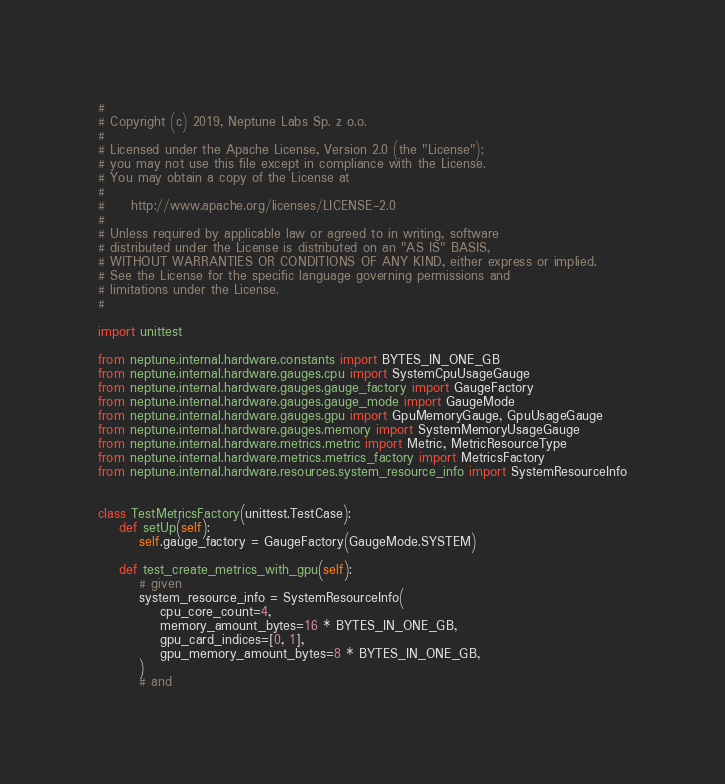Convert code to text. <code><loc_0><loc_0><loc_500><loc_500><_Python_>#
# Copyright (c) 2019, Neptune Labs Sp. z o.o.
#
# Licensed under the Apache License, Version 2.0 (the "License");
# you may not use this file except in compliance with the License.
# You may obtain a copy of the License at
#
#     http://www.apache.org/licenses/LICENSE-2.0
#
# Unless required by applicable law or agreed to in writing, software
# distributed under the License is distributed on an "AS IS" BASIS,
# WITHOUT WARRANTIES OR CONDITIONS OF ANY KIND, either express or implied.
# See the License for the specific language governing permissions and
# limitations under the License.
#

import unittest

from neptune.internal.hardware.constants import BYTES_IN_ONE_GB
from neptune.internal.hardware.gauges.cpu import SystemCpuUsageGauge
from neptune.internal.hardware.gauges.gauge_factory import GaugeFactory
from neptune.internal.hardware.gauges.gauge_mode import GaugeMode
from neptune.internal.hardware.gauges.gpu import GpuMemoryGauge, GpuUsageGauge
from neptune.internal.hardware.gauges.memory import SystemMemoryUsageGauge
from neptune.internal.hardware.metrics.metric import Metric, MetricResourceType
from neptune.internal.hardware.metrics.metrics_factory import MetricsFactory
from neptune.internal.hardware.resources.system_resource_info import SystemResourceInfo


class TestMetricsFactory(unittest.TestCase):
    def setUp(self):
        self.gauge_factory = GaugeFactory(GaugeMode.SYSTEM)

    def test_create_metrics_with_gpu(self):
        # given
        system_resource_info = SystemResourceInfo(
            cpu_core_count=4,
            memory_amount_bytes=16 * BYTES_IN_ONE_GB,
            gpu_card_indices=[0, 1],
            gpu_memory_amount_bytes=8 * BYTES_IN_ONE_GB,
        )
        # and</code> 